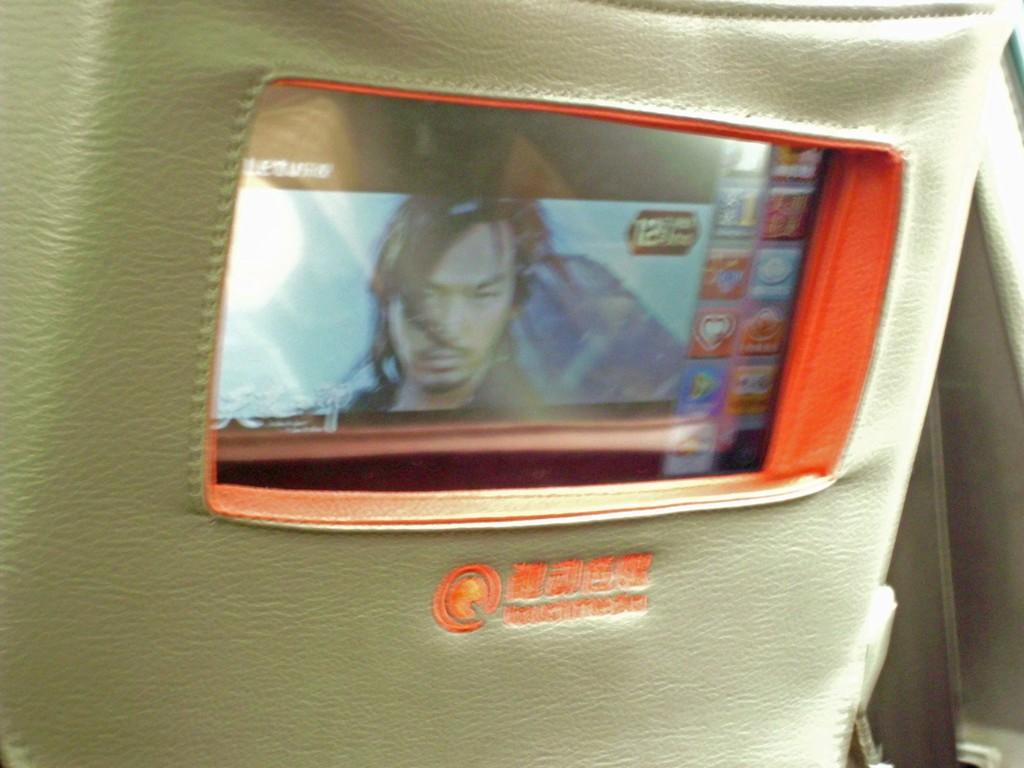What is the main object in the image? There is an object that looks like a vehicle seat in the image. What is attached to the vehicle seat? There is a screen attached to the vehicle seat in the image. How many pets are visible on the vehicle seat in the image? There are no pets visible on the vehicle seat in the image. What type of blade is used to cut the screen in the image? There is no blade or cutting action depicted in the image; the screen is attached to the vehicle seat. 